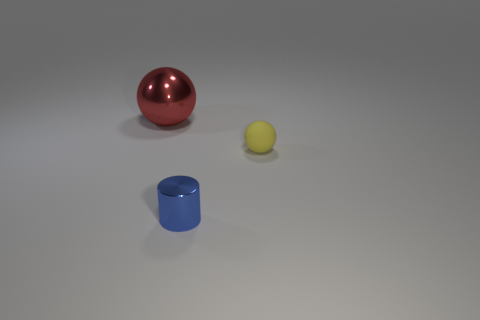What shape is the large red thing that is made of the same material as the small blue object?
Your response must be concise. Sphere. What is the shape of the matte object?
Your response must be concise. Sphere. What is the color of the object that is to the left of the matte sphere and in front of the big red ball?
Your answer should be compact. Blue. What is the shape of the yellow object that is the same size as the cylinder?
Provide a short and direct response. Sphere. Are there any other yellow rubber objects that have the same shape as the large object?
Provide a succinct answer. Yes. Is the big ball made of the same material as the tiny object on the left side of the tiny rubber thing?
Make the answer very short. Yes. There is a metal thing that is to the left of the shiny thing that is in front of the shiny thing that is behind the tiny blue metallic cylinder; what is its color?
Make the answer very short. Red. There is a cylinder that is the same size as the yellow rubber thing; what is its material?
Your response must be concise. Metal. How many other tiny objects have the same material as the small yellow object?
Keep it short and to the point. 0. There is a thing right of the blue shiny cylinder; does it have the same size as the thing that is in front of the small sphere?
Your response must be concise. Yes. 